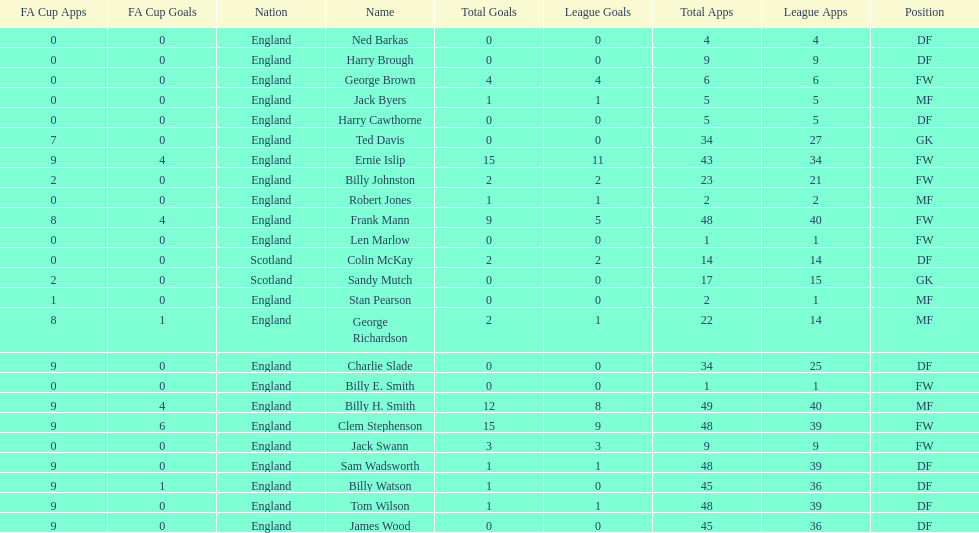What is the last name listed on this chart? James Wood. 